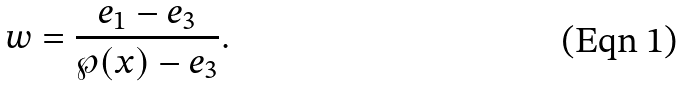Convert formula to latex. <formula><loc_0><loc_0><loc_500><loc_500>w = \frac { e _ { 1 } - e _ { 3 } } { \wp ( x ) - e _ { 3 } } .</formula> 